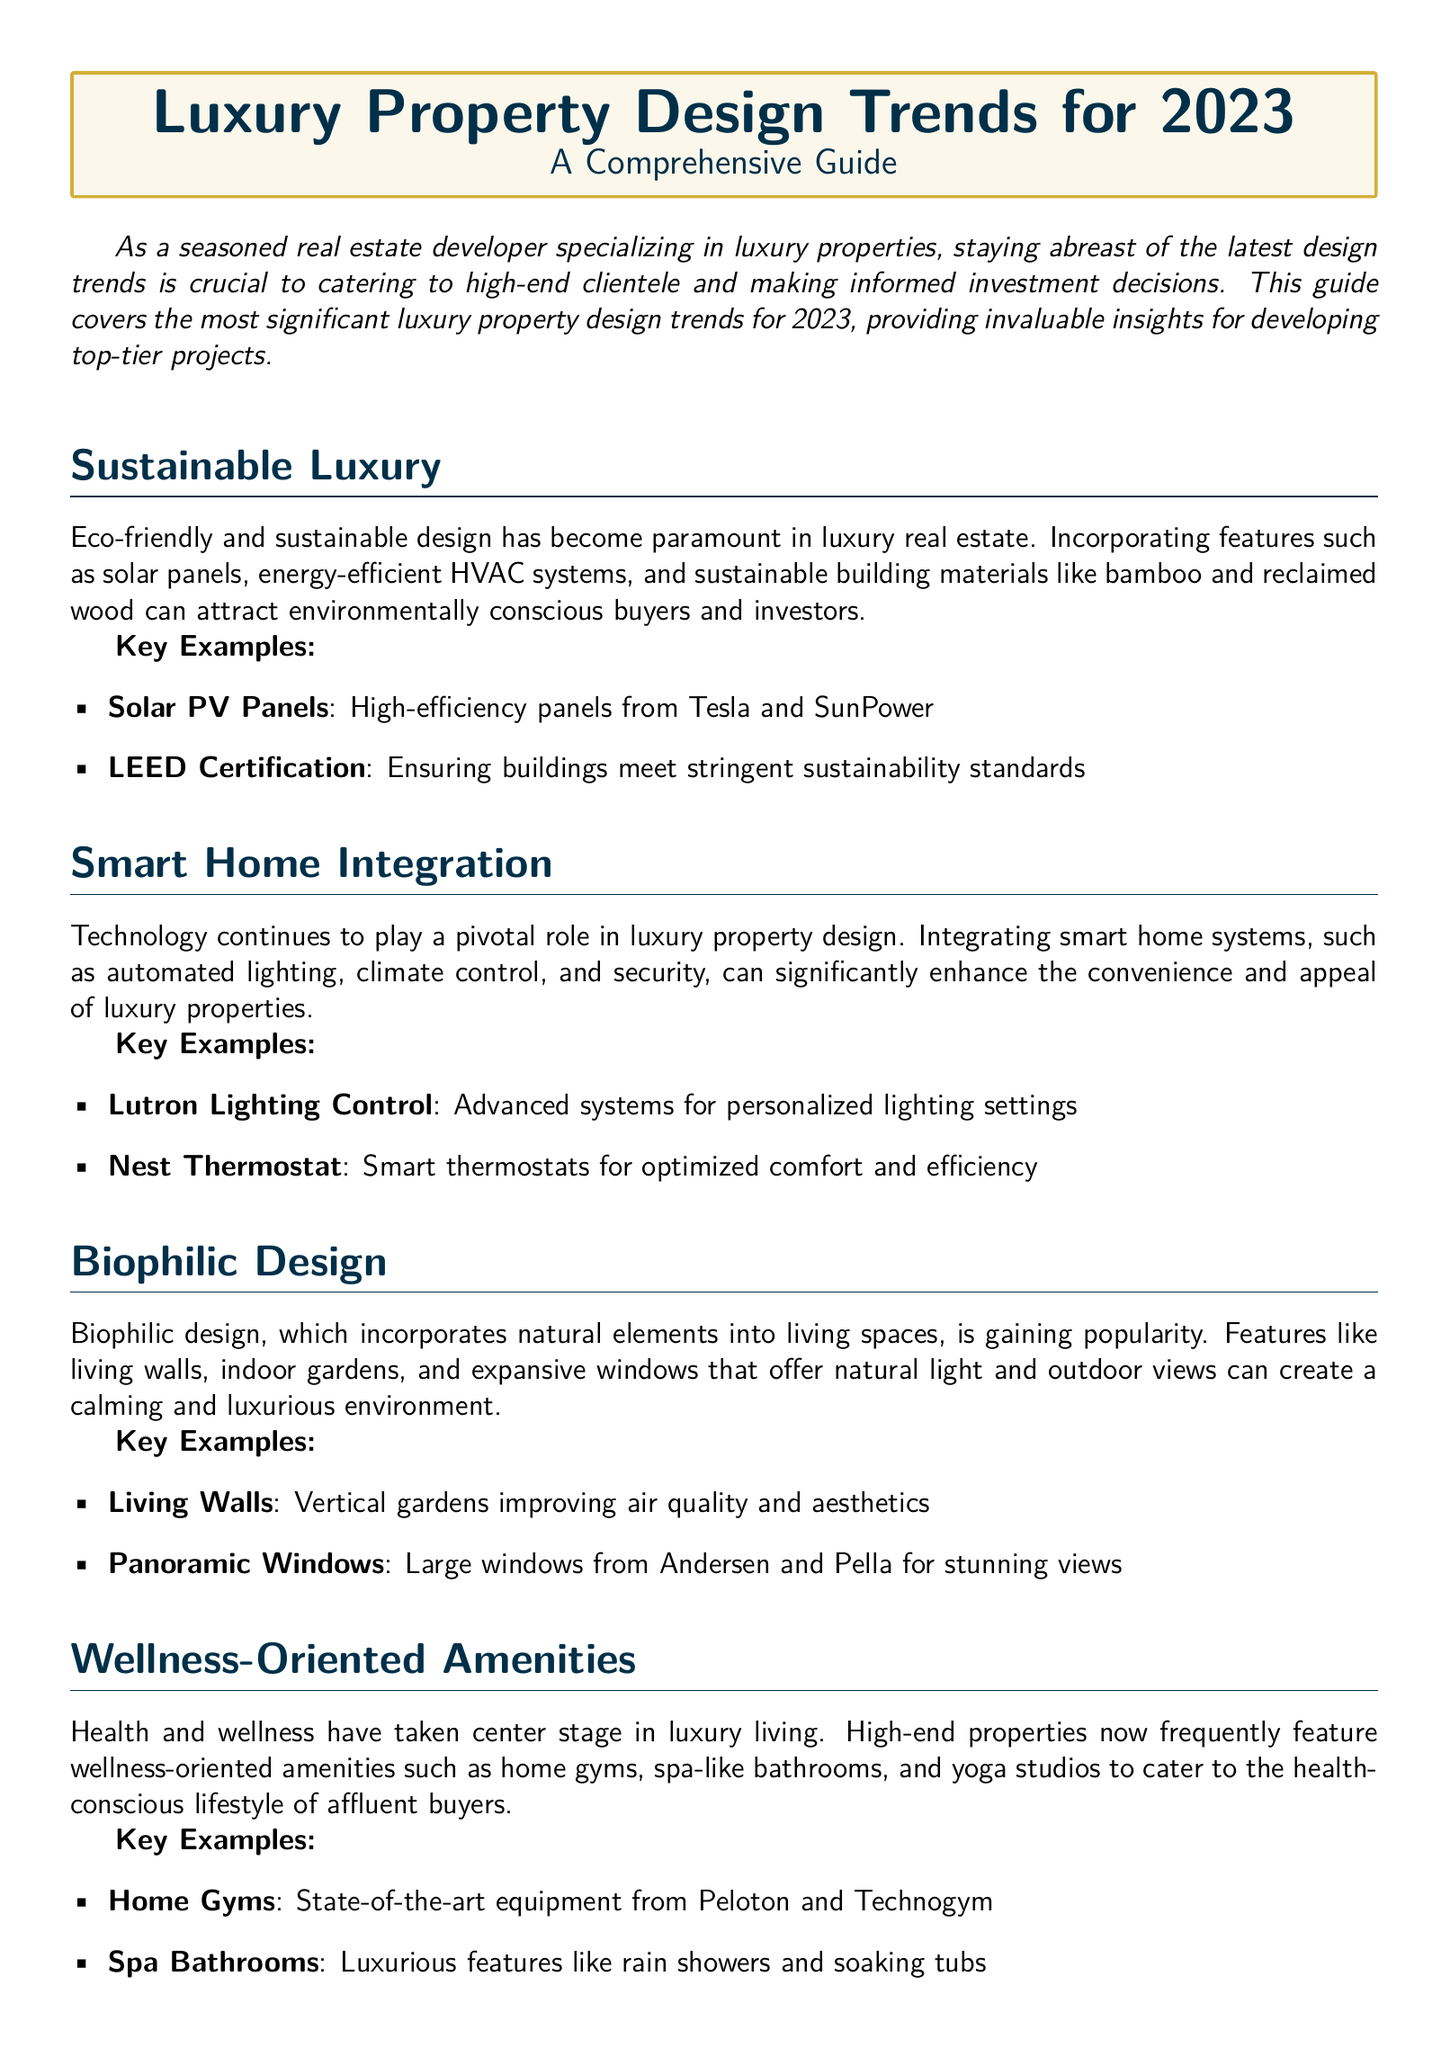What is the first design trend mentioned? The first design trend discussed in the document is Sustainable Luxury.
Answer: Sustainable Luxury What technology is highlighted under Smart Home Integration? The document mentions automated lighting, climate control, and security as part of Smart Home Integration.
Answer: Automated lighting What building features are examples of Sustainable Luxury? Examples such as solar panels and sustainable building materials, like bamboo and reclaimed wood, are provided in the document.
Answer: Solar panels Which window type is featured in the Biophilic Design section? The document mentions panoramic windows specifically as part of the Biophilic Design features.
Answer: Panoramic Windows What is a key amenity highlighted for wellness? The document lists home gyms as significant wellness-oriented amenities in luxury properties.
Answer: Home Gyms What trend emphasizes large, flowing spaces? Open Concept Living is the trend that emphasizes large, flowing spaces according to the document.
Answer: Open Concept Living Which brand is associated with state-of-the-art home gym equipment? The document states that Peloton provides state-of-the-art equipment for home gyms.
Answer: Peloton What certification is mentioned under Sustainable Luxury? LEED Certification is one of the certifications related to Sustainable Luxury in the document.
Answer: LEED Certification 